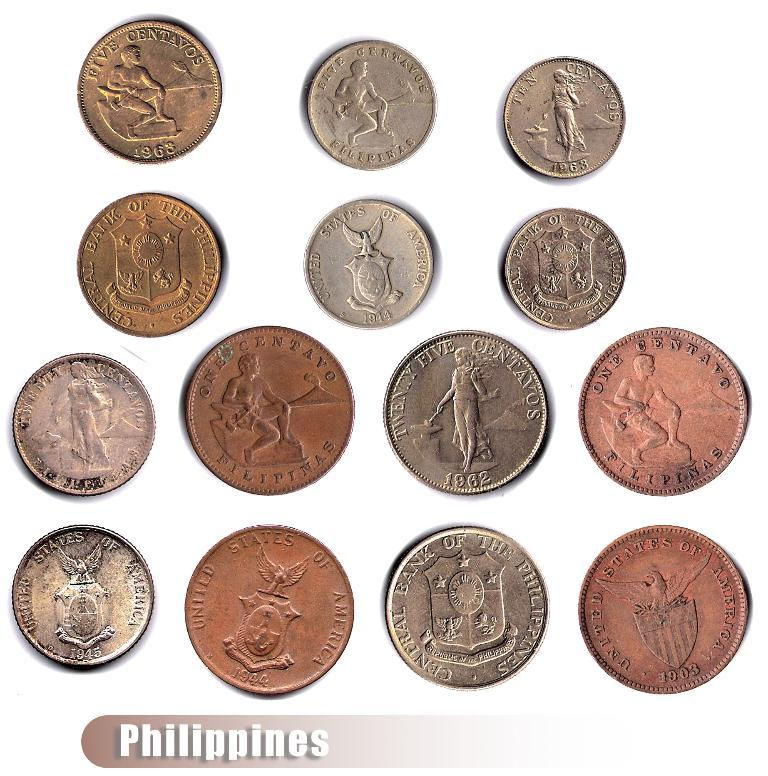<image>
Render a clear and concise summary of the photo. A collection of fourteen Philippine coins, including one from 1903. 